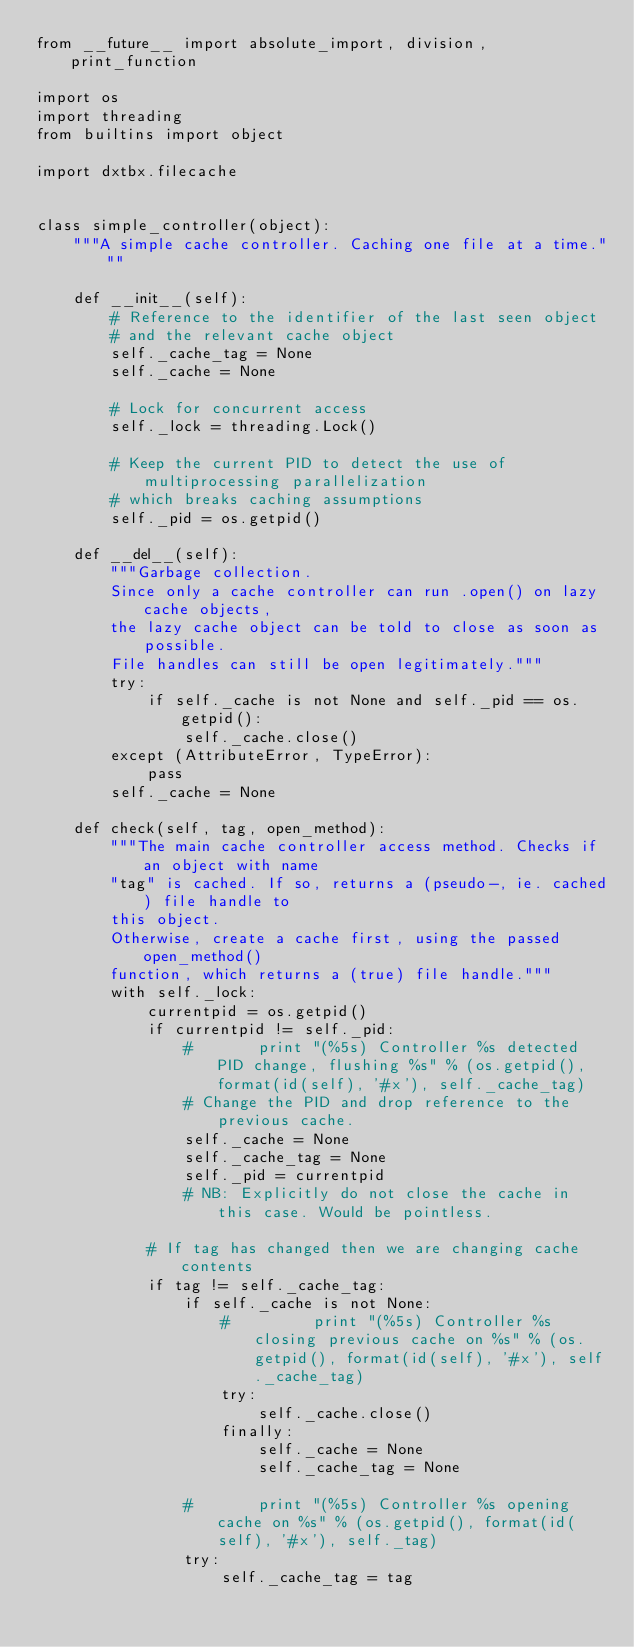<code> <loc_0><loc_0><loc_500><loc_500><_Python_>from __future__ import absolute_import, division, print_function

import os
import threading
from builtins import object

import dxtbx.filecache


class simple_controller(object):
    """A simple cache controller. Caching one file at a time."""

    def __init__(self):
        # Reference to the identifier of the last seen object
        # and the relevant cache object
        self._cache_tag = None
        self._cache = None

        # Lock for concurrent access
        self._lock = threading.Lock()

        # Keep the current PID to detect the use of multiprocessing parallelization
        # which breaks caching assumptions
        self._pid = os.getpid()

    def __del__(self):
        """Garbage collection.
        Since only a cache controller can run .open() on lazy cache objects,
        the lazy cache object can be told to close as soon as possible.
        File handles can still be open legitimately."""
        try:
            if self._cache is not None and self._pid == os.getpid():
                self._cache.close()
        except (AttributeError, TypeError):
            pass
        self._cache = None

    def check(self, tag, open_method):
        """The main cache controller access method. Checks if an object with name
        "tag" is cached. If so, returns a (pseudo-, ie. cached) file handle to
        this object.
        Otherwise, create a cache first, using the passed open_method()
        function, which returns a (true) file handle."""
        with self._lock:
            currentpid = os.getpid()
            if currentpid != self._pid:
                #       print "(%5s) Controller %s detected PID change, flushing %s" % (os.getpid(), format(id(self), '#x'), self._cache_tag)
                # Change the PID and drop reference to the previous cache.
                self._cache = None
                self._cache_tag = None
                self._pid = currentpid
                # NB: Explicitly do not close the cache in this case. Would be pointless.

            # If tag has changed then we are changing cache contents
            if tag != self._cache_tag:
                if self._cache is not None:
                    #         print "(%5s) Controller %s closing previous cache on %s" % (os.getpid(), format(id(self), '#x'), self._cache_tag)
                    try:
                        self._cache.close()
                    finally:
                        self._cache = None
                        self._cache_tag = None

                #       print "(%5s) Controller %s opening cache on %s" % (os.getpid(), format(id(self), '#x'), self._tag)
                try:
                    self._cache_tag = tag</code> 